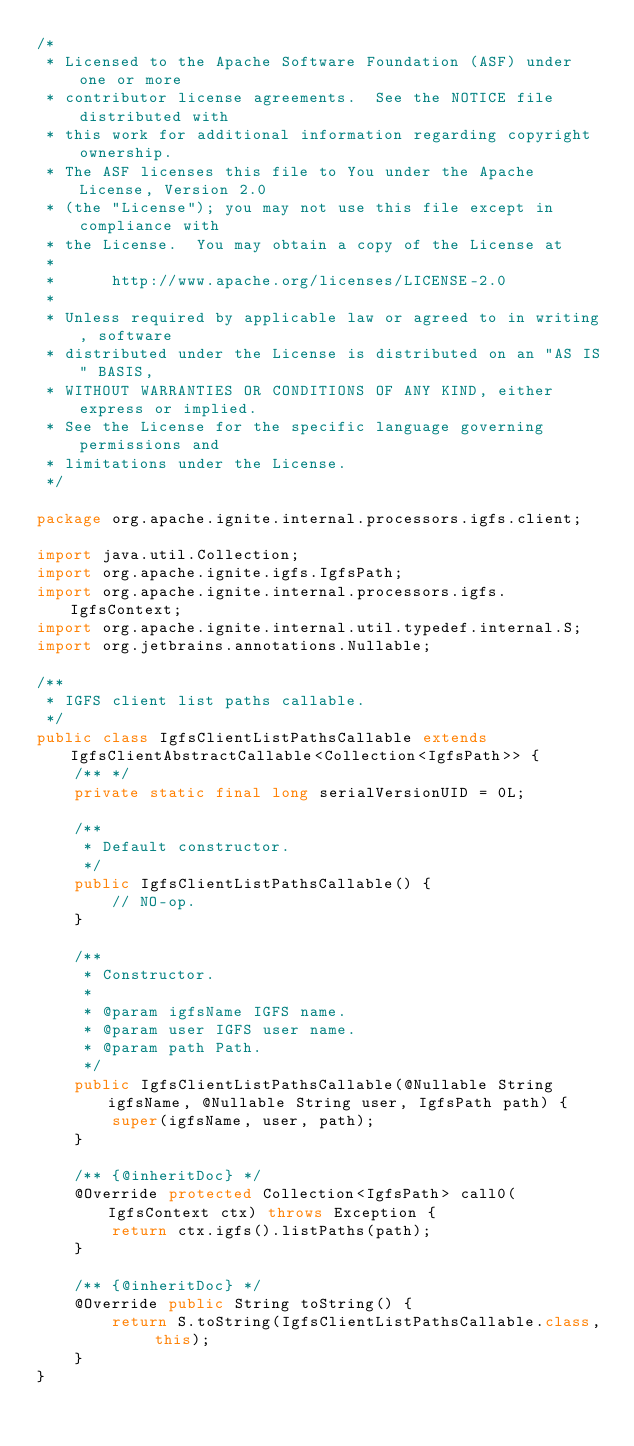Convert code to text. <code><loc_0><loc_0><loc_500><loc_500><_Java_>/*
 * Licensed to the Apache Software Foundation (ASF) under one or more
 * contributor license agreements.  See the NOTICE file distributed with
 * this work for additional information regarding copyright ownership.
 * The ASF licenses this file to You under the Apache License, Version 2.0
 * (the "License"); you may not use this file except in compliance with
 * the License.  You may obtain a copy of the License at
 *
 *      http://www.apache.org/licenses/LICENSE-2.0
 *
 * Unless required by applicable law or agreed to in writing, software
 * distributed under the License is distributed on an "AS IS" BASIS,
 * WITHOUT WARRANTIES OR CONDITIONS OF ANY KIND, either express or implied.
 * See the License for the specific language governing permissions and
 * limitations under the License.
 */

package org.apache.ignite.internal.processors.igfs.client;

import java.util.Collection;
import org.apache.ignite.igfs.IgfsPath;
import org.apache.ignite.internal.processors.igfs.IgfsContext;
import org.apache.ignite.internal.util.typedef.internal.S;
import org.jetbrains.annotations.Nullable;

/**
 * IGFS client list paths callable.
 */
public class IgfsClientListPathsCallable extends IgfsClientAbstractCallable<Collection<IgfsPath>> {
    /** */
    private static final long serialVersionUID = 0L;

    /**
     * Default constructor.
     */
    public IgfsClientListPathsCallable() {
        // NO-op.
    }

    /**
     * Constructor.
     *
     * @param igfsName IGFS name.
     * @param user IGFS user name.
     * @param path Path.
     */
    public IgfsClientListPathsCallable(@Nullable String igfsName, @Nullable String user, IgfsPath path) {
        super(igfsName, user, path);
    }

    /** {@inheritDoc} */
    @Override protected Collection<IgfsPath> call0(IgfsContext ctx) throws Exception {
        return ctx.igfs().listPaths(path);
    }

    /** {@inheritDoc} */
    @Override public String toString() {
        return S.toString(IgfsClientListPathsCallable.class, this);
    }
}
</code> 